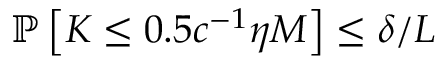<formula> <loc_0><loc_0><loc_500><loc_500>\mathbb { P } \left [ K \leq 0 . 5 c ^ { - 1 } \eta M \right ] \leq \delta / L</formula> 